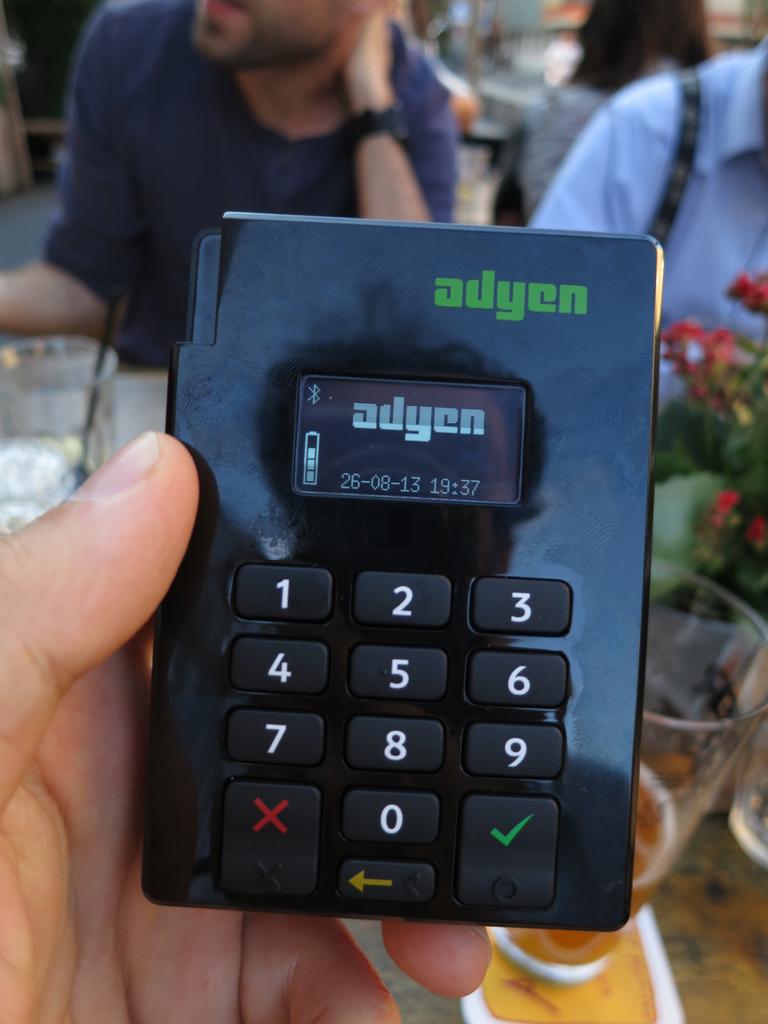What company made this phone?
Make the answer very short. Adyen. What time is it according to this phone?
Provide a succinct answer. 19:37. 